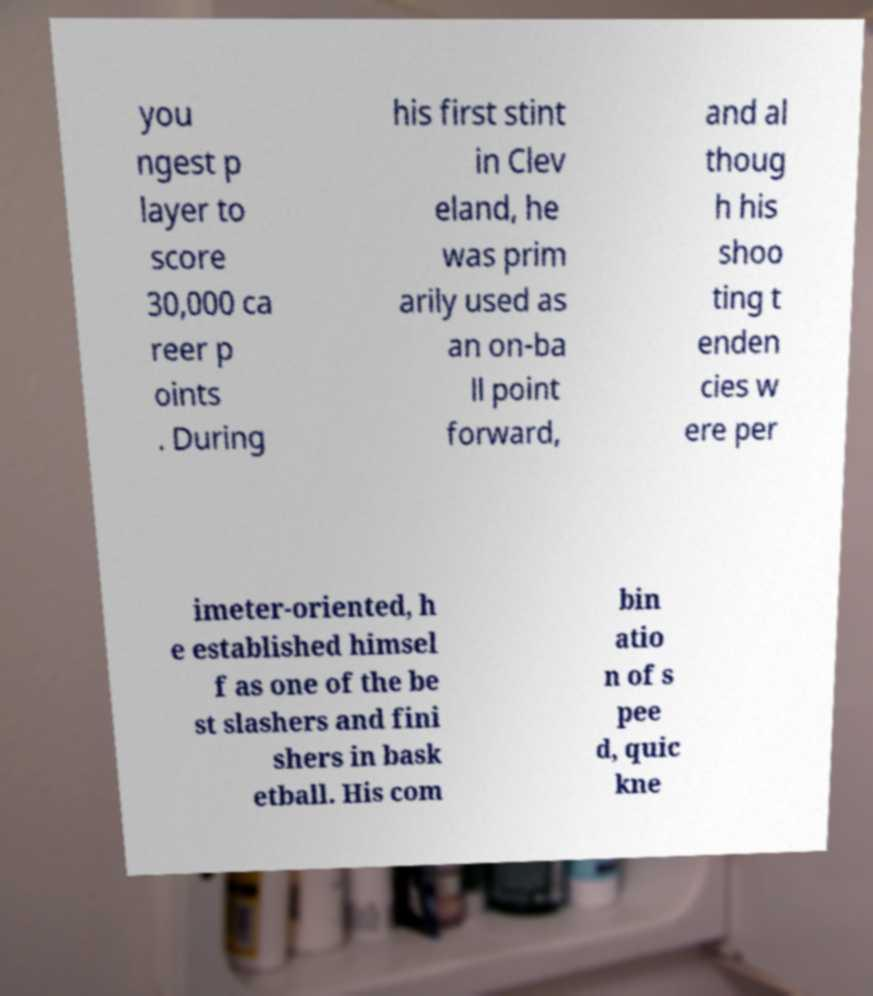Can you accurately transcribe the text from the provided image for me? you ngest p layer to score 30,000 ca reer p oints . During his first stint in Clev eland, he was prim arily used as an on-ba ll point forward, and al thoug h his shoo ting t enden cies w ere per imeter-oriented, h e established himsel f as one of the be st slashers and fini shers in bask etball. His com bin atio n of s pee d, quic kne 